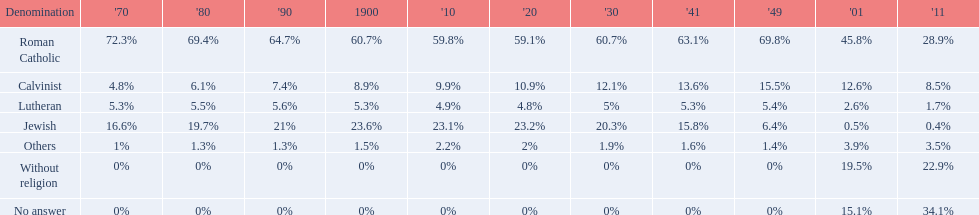In which year was the percentage of those without religion at least 20%? 2011. 